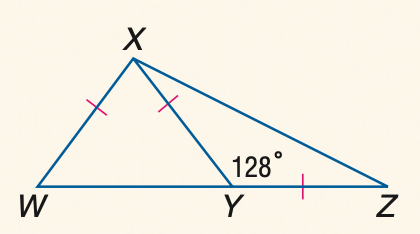Answer the mathemtical geometry problem and directly provide the correct option letter.
Question: \triangle W X Y and \triangle X Y Z are isosceles and m \angle X Y Z = 128. Find the measure of \angle Y Z X.
Choices: A: 22 B: 24 C: 26 D: 28 C 